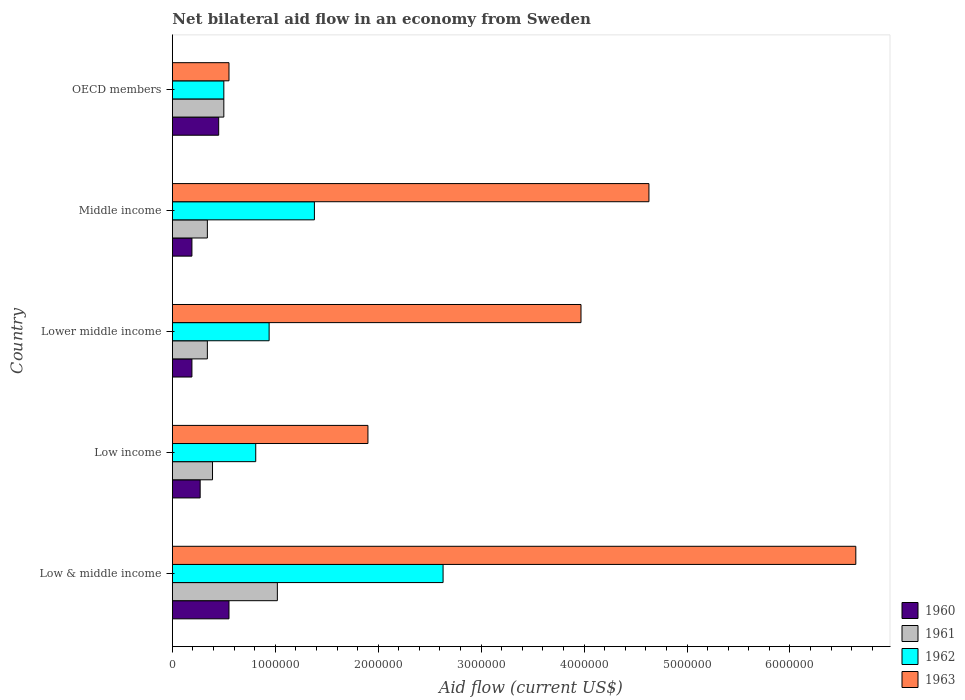How many groups of bars are there?
Your answer should be compact. 5. What is the label of the 3rd group of bars from the top?
Keep it short and to the point. Lower middle income. What is the net bilateral aid flow in 1962 in Lower middle income?
Give a very brief answer. 9.40e+05. Across all countries, what is the maximum net bilateral aid flow in 1961?
Your answer should be very brief. 1.02e+06. Across all countries, what is the minimum net bilateral aid flow in 1963?
Give a very brief answer. 5.50e+05. In which country was the net bilateral aid flow in 1963 minimum?
Give a very brief answer. OECD members. What is the total net bilateral aid flow in 1960 in the graph?
Offer a very short reply. 1.65e+06. What is the difference between the net bilateral aid flow in 1962 in Low & middle income and that in Low income?
Provide a succinct answer. 1.82e+06. What is the difference between the net bilateral aid flow in 1962 in Lower middle income and the net bilateral aid flow in 1960 in Middle income?
Give a very brief answer. 7.50e+05. What is the average net bilateral aid flow in 1962 per country?
Give a very brief answer. 1.25e+06. What is the difference between the net bilateral aid flow in 1960 and net bilateral aid flow in 1963 in Low & middle income?
Ensure brevity in your answer.  -6.09e+06. What is the ratio of the net bilateral aid flow in 1963 in Low income to that in Lower middle income?
Offer a very short reply. 0.48. Is the difference between the net bilateral aid flow in 1960 in Low & middle income and Middle income greater than the difference between the net bilateral aid flow in 1963 in Low & middle income and Middle income?
Provide a succinct answer. No. What is the difference between the highest and the lowest net bilateral aid flow in 1961?
Your answer should be compact. 6.80e+05. In how many countries, is the net bilateral aid flow in 1962 greater than the average net bilateral aid flow in 1962 taken over all countries?
Your answer should be very brief. 2. Is the sum of the net bilateral aid flow in 1960 in Low income and Middle income greater than the maximum net bilateral aid flow in 1963 across all countries?
Your answer should be compact. No. What does the 3rd bar from the top in Lower middle income represents?
Your answer should be very brief. 1961. What does the 2nd bar from the bottom in Middle income represents?
Your answer should be compact. 1961. Is it the case that in every country, the sum of the net bilateral aid flow in 1963 and net bilateral aid flow in 1962 is greater than the net bilateral aid flow in 1960?
Your answer should be compact. Yes. How many bars are there?
Provide a short and direct response. 20. Are all the bars in the graph horizontal?
Ensure brevity in your answer.  Yes. How many countries are there in the graph?
Your answer should be compact. 5. How many legend labels are there?
Your answer should be compact. 4. What is the title of the graph?
Provide a succinct answer. Net bilateral aid flow in an economy from Sweden. What is the label or title of the X-axis?
Offer a terse response. Aid flow (current US$). What is the label or title of the Y-axis?
Your answer should be compact. Country. What is the Aid flow (current US$) in 1960 in Low & middle income?
Your answer should be compact. 5.50e+05. What is the Aid flow (current US$) in 1961 in Low & middle income?
Provide a succinct answer. 1.02e+06. What is the Aid flow (current US$) in 1962 in Low & middle income?
Your response must be concise. 2.63e+06. What is the Aid flow (current US$) of 1963 in Low & middle income?
Give a very brief answer. 6.64e+06. What is the Aid flow (current US$) of 1961 in Low income?
Make the answer very short. 3.90e+05. What is the Aid flow (current US$) in 1962 in Low income?
Your answer should be very brief. 8.10e+05. What is the Aid flow (current US$) in 1963 in Low income?
Offer a terse response. 1.90e+06. What is the Aid flow (current US$) in 1962 in Lower middle income?
Offer a terse response. 9.40e+05. What is the Aid flow (current US$) in 1963 in Lower middle income?
Your response must be concise. 3.97e+06. What is the Aid flow (current US$) in 1960 in Middle income?
Keep it short and to the point. 1.90e+05. What is the Aid flow (current US$) of 1962 in Middle income?
Your answer should be very brief. 1.38e+06. What is the Aid flow (current US$) in 1963 in Middle income?
Provide a succinct answer. 4.63e+06. What is the Aid flow (current US$) of 1960 in OECD members?
Keep it short and to the point. 4.50e+05. What is the Aid flow (current US$) in 1961 in OECD members?
Offer a terse response. 5.00e+05. Across all countries, what is the maximum Aid flow (current US$) of 1961?
Keep it short and to the point. 1.02e+06. Across all countries, what is the maximum Aid flow (current US$) in 1962?
Keep it short and to the point. 2.63e+06. Across all countries, what is the maximum Aid flow (current US$) of 1963?
Ensure brevity in your answer.  6.64e+06. Across all countries, what is the minimum Aid flow (current US$) of 1960?
Offer a very short reply. 1.90e+05. Across all countries, what is the minimum Aid flow (current US$) of 1961?
Make the answer very short. 3.40e+05. What is the total Aid flow (current US$) in 1960 in the graph?
Make the answer very short. 1.65e+06. What is the total Aid flow (current US$) of 1961 in the graph?
Your answer should be compact. 2.59e+06. What is the total Aid flow (current US$) in 1962 in the graph?
Ensure brevity in your answer.  6.26e+06. What is the total Aid flow (current US$) of 1963 in the graph?
Your answer should be compact. 1.77e+07. What is the difference between the Aid flow (current US$) in 1960 in Low & middle income and that in Low income?
Ensure brevity in your answer.  2.80e+05. What is the difference between the Aid flow (current US$) in 1961 in Low & middle income and that in Low income?
Your answer should be very brief. 6.30e+05. What is the difference between the Aid flow (current US$) of 1962 in Low & middle income and that in Low income?
Offer a terse response. 1.82e+06. What is the difference between the Aid flow (current US$) of 1963 in Low & middle income and that in Low income?
Make the answer very short. 4.74e+06. What is the difference between the Aid flow (current US$) of 1960 in Low & middle income and that in Lower middle income?
Your answer should be very brief. 3.60e+05. What is the difference between the Aid flow (current US$) in 1961 in Low & middle income and that in Lower middle income?
Make the answer very short. 6.80e+05. What is the difference between the Aid flow (current US$) of 1962 in Low & middle income and that in Lower middle income?
Your answer should be compact. 1.69e+06. What is the difference between the Aid flow (current US$) in 1963 in Low & middle income and that in Lower middle income?
Provide a succinct answer. 2.67e+06. What is the difference between the Aid flow (current US$) in 1961 in Low & middle income and that in Middle income?
Give a very brief answer. 6.80e+05. What is the difference between the Aid flow (current US$) of 1962 in Low & middle income and that in Middle income?
Provide a succinct answer. 1.25e+06. What is the difference between the Aid flow (current US$) of 1963 in Low & middle income and that in Middle income?
Keep it short and to the point. 2.01e+06. What is the difference between the Aid flow (current US$) of 1960 in Low & middle income and that in OECD members?
Provide a short and direct response. 1.00e+05. What is the difference between the Aid flow (current US$) of 1961 in Low & middle income and that in OECD members?
Provide a short and direct response. 5.20e+05. What is the difference between the Aid flow (current US$) of 1962 in Low & middle income and that in OECD members?
Offer a terse response. 2.13e+06. What is the difference between the Aid flow (current US$) of 1963 in Low & middle income and that in OECD members?
Offer a terse response. 6.09e+06. What is the difference between the Aid flow (current US$) in 1961 in Low income and that in Lower middle income?
Provide a short and direct response. 5.00e+04. What is the difference between the Aid flow (current US$) in 1963 in Low income and that in Lower middle income?
Make the answer very short. -2.07e+06. What is the difference between the Aid flow (current US$) in 1962 in Low income and that in Middle income?
Provide a short and direct response. -5.70e+05. What is the difference between the Aid flow (current US$) in 1963 in Low income and that in Middle income?
Ensure brevity in your answer.  -2.73e+06. What is the difference between the Aid flow (current US$) in 1960 in Low income and that in OECD members?
Make the answer very short. -1.80e+05. What is the difference between the Aid flow (current US$) of 1963 in Low income and that in OECD members?
Provide a short and direct response. 1.35e+06. What is the difference between the Aid flow (current US$) in 1962 in Lower middle income and that in Middle income?
Your response must be concise. -4.40e+05. What is the difference between the Aid flow (current US$) of 1963 in Lower middle income and that in Middle income?
Provide a short and direct response. -6.60e+05. What is the difference between the Aid flow (current US$) in 1960 in Lower middle income and that in OECD members?
Make the answer very short. -2.60e+05. What is the difference between the Aid flow (current US$) of 1963 in Lower middle income and that in OECD members?
Make the answer very short. 3.42e+06. What is the difference between the Aid flow (current US$) of 1960 in Middle income and that in OECD members?
Make the answer very short. -2.60e+05. What is the difference between the Aid flow (current US$) in 1962 in Middle income and that in OECD members?
Your response must be concise. 8.80e+05. What is the difference between the Aid flow (current US$) of 1963 in Middle income and that in OECD members?
Your response must be concise. 4.08e+06. What is the difference between the Aid flow (current US$) of 1960 in Low & middle income and the Aid flow (current US$) of 1963 in Low income?
Make the answer very short. -1.35e+06. What is the difference between the Aid flow (current US$) of 1961 in Low & middle income and the Aid flow (current US$) of 1963 in Low income?
Your answer should be very brief. -8.80e+05. What is the difference between the Aid flow (current US$) in 1962 in Low & middle income and the Aid flow (current US$) in 1963 in Low income?
Keep it short and to the point. 7.30e+05. What is the difference between the Aid flow (current US$) of 1960 in Low & middle income and the Aid flow (current US$) of 1961 in Lower middle income?
Make the answer very short. 2.10e+05. What is the difference between the Aid flow (current US$) of 1960 in Low & middle income and the Aid flow (current US$) of 1962 in Lower middle income?
Provide a succinct answer. -3.90e+05. What is the difference between the Aid flow (current US$) of 1960 in Low & middle income and the Aid flow (current US$) of 1963 in Lower middle income?
Offer a very short reply. -3.42e+06. What is the difference between the Aid flow (current US$) of 1961 in Low & middle income and the Aid flow (current US$) of 1963 in Lower middle income?
Provide a succinct answer. -2.95e+06. What is the difference between the Aid flow (current US$) in 1962 in Low & middle income and the Aid flow (current US$) in 1963 in Lower middle income?
Provide a short and direct response. -1.34e+06. What is the difference between the Aid flow (current US$) of 1960 in Low & middle income and the Aid flow (current US$) of 1961 in Middle income?
Make the answer very short. 2.10e+05. What is the difference between the Aid flow (current US$) of 1960 in Low & middle income and the Aid flow (current US$) of 1962 in Middle income?
Your answer should be very brief. -8.30e+05. What is the difference between the Aid flow (current US$) in 1960 in Low & middle income and the Aid flow (current US$) in 1963 in Middle income?
Your answer should be very brief. -4.08e+06. What is the difference between the Aid flow (current US$) of 1961 in Low & middle income and the Aid flow (current US$) of 1962 in Middle income?
Give a very brief answer. -3.60e+05. What is the difference between the Aid flow (current US$) of 1961 in Low & middle income and the Aid flow (current US$) of 1963 in Middle income?
Make the answer very short. -3.61e+06. What is the difference between the Aid flow (current US$) in 1960 in Low & middle income and the Aid flow (current US$) in 1961 in OECD members?
Your answer should be compact. 5.00e+04. What is the difference between the Aid flow (current US$) of 1961 in Low & middle income and the Aid flow (current US$) of 1962 in OECD members?
Make the answer very short. 5.20e+05. What is the difference between the Aid flow (current US$) of 1961 in Low & middle income and the Aid flow (current US$) of 1963 in OECD members?
Your answer should be compact. 4.70e+05. What is the difference between the Aid flow (current US$) of 1962 in Low & middle income and the Aid flow (current US$) of 1963 in OECD members?
Give a very brief answer. 2.08e+06. What is the difference between the Aid flow (current US$) of 1960 in Low income and the Aid flow (current US$) of 1962 in Lower middle income?
Provide a succinct answer. -6.70e+05. What is the difference between the Aid flow (current US$) in 1960 in Low income and the Aid flow (current US$) in 1963 in Lower middle income?
Your answer should be compact. -3.70e+06. What is the difference between the Aid flow (current US$) in 1961 in Low income and the Aid flow (current US$) in 1962 in Lower middle income?
Give a very brief answer. -5.50e+05. What is the difference between the Aid flow (current US$) in 1961 in Low income and the Aid flow (current US$) in 1963 in Lower middle income?
Make the answer very short. -3.58e+06. What is the difference between the Aid flow (current US$) of 1962 in Low income and the Aid flow (current US$) of 1963 in Lower middle income?
Keep it short and to the point. -3.16e+06. What is the difference between the Aid flow (current US$) in 1960 in Low income and the Aid flow (current US$) in 1962 in Middle income?
Give a very brief answer. -1.11e+06. What is the difference between the Aid flow (current US$) in 1960 in Low income and the Aid flow (current US$) in 1963 in Middle income?
Your answer should be very brief. -4.36e+06. What is the difference between the Aid flow (current US$) of 1961 in Low income and the Aid flow (current US$) of 1962 in Middle income?
Keep it short and to the point. -9.90e+05. What is the difference between the Aid flow (current US$) in 1961 in Low income and the Aid flow (current US$) in 1963 in Middle income?
Your response must be concise. -4.24e+06. What is the difference between the Aid flow (current US$) of 1962 in Low income and the Aid flow (current US$) of 1963 in Middle income?
Your answer should be very brief. -3.82e+06. What is the difference between the Aid flow (current US$) in 1960 in Low income and the Aid flow (current US$) in 1961 in OECD members?
Offer a terse response. -2.30e+05. What is the difference between the Aid flow (current US$) of 1960 in Low income and the Aid flow (current US$) of 1963 in OECD members?
Your response must be concise. -2.80e+05. What is the difference between the Aid flow (current US$) in 1960 in Lower middle income and the Aid flow (current US$) in 1961 in Middle income?
Offer a very short reply. -1.50e+05. What is the difference between the Aid flow (current US$) of 1960 in Lower middle income and the Aid flow (current US$) of 1962 in Middle income?
Ensure brevity in your answer.  -1.19e+06. What is the difference between the Aid flow (current US$) of 1960 in Lower middle income and the Aid flow (current US$) of 1963 in Middle income?
Provide a succinct answer. -4.44e+06. What is the difference between the Aid flow (current US$) of 1961 in Lower middle income and the Aid flow (current US$) of 1962 in Middle income?
Your response must be concise. -1.04e+06. What is the difference between the Aid flow (current US$) of 1961 in Lower middle income and the Aid flow (current US$) of 1963 in Middle income?
Your answer should be compact. -4.29e+06. What is the difference between the Aid flow (current US$) of 1962 in Lower middle income and the Aid flow (current US$) of 1963 in Middle income?
Offer a very short reply. -3.69e+06. What is the difference between the Aid flow (current US$) in 1960 in Lower middle income and the Aid flow (current US$) in 1961 in OECD members?
Ensure brevity in your answer.  -3.10e+05. What is the difference between the Aid flow (current US$) in 1960 in Lower middle income and the Aid flow (current US$) in 1962 in OECD members?
Your answer should be compact. -3.10e+05. What is the difference between the Aid flow (current US$) in 1960 in Lower middle income and the Aid flow (current US$) in 1963 in OECD members?
Offer a terse response. -3.60e+05. What is the difference between the Aid flow (current US$) of 1961 in Lower middle income and the Aid flow (current US$) of 1962 in OECD members?
Your response must be concise. -1.60e+05. What is the difference between the Aid flow (current US$) in 1960 in Middle income and the Aid flow (current US$) in 1961 in OECD members?
Your answer should be compact. -3.10e+05. What is the difference between the Aid flow (current US$) of 1960 in Middle income and the Aid flow (current US$) of 1962 in OECD members?
Ensure brevity in your answer.  -3.10e+05. What is the difference between the Aid flow (current US$) in 1960 in Middle income and the Aid flow (current US$) in 1963 in OECD members?
Offer a very short reply. -3.60e+05. What is the difference between the Aid flow (current US$) in 1961 in Middle income and the Aid flow (current US$) in 1962 in OECD members?
Give a very brief answer. -1.60e+05. What is the difference between the Aid flow (current US$) of 1961 in Middle income and the Aid flow (current US$) of 1963 in OECD members?
Keep it short and to the point. -2.10e+05. What is the difference between the Aid flow (current US$) in 1962 in Middle income and the Aid flow (current US$) in 1963 in OECD members?
Your answer should be very brief. 8.30e+05. What is the average Aid flow (current US$) of 1960 per country?
Offer a terse response. 3.30e+05. What is the average Aid flow (current US$) in 1961 per country?
Offer a very short reply. 5.18e+05. What is the average Aid flow (current US$) in 1962 per country?
Offer a terse response. 1.25e+06. What is the average Aid flow (current US$) of 1963 per country?
Your answer should be compact. 3.54e+06. What is the difference between the Aid flow (current US$) in 1960 and Aid flow (current US$) in 1961 in Low & middle income?
Your answer should be very brief. -4.70e+05. What is the difference between the Aid flow (current US$) of 1960 and Aid flow (current US$) of 1962 in Low & middle income?
Ensure brevity in your answer.  -2.08e+06. What is the difference between the Aid flow (current US$) in 1960 and Aid flow (current US$) in 1963 in Low & middle income?
Keep it short and to the point. -6.09e+06. What is the difference between the Aid flow (current US$) of 1961 and Aid flow (current US$) of 1962 in Low & middle income?
Your response must be concise. -1.61e+06. What is the difference between the Aid flow (current US$) of 1961 and Aid flow (current US$) of 1963 in Low & middle income?
Provide a short and direct response. -5.62e+06. What is the difference between the Aid flow (current US$) in 1962 and Aid flow (current US$) in 1963 in Low & middle income?
Offer a very short reply. -4.01e+06. What is the difference between the Aid flow (current US$) in 1960 and Aid flow (current US$) in 1962 in Low income?
Ensure brevity in your answer.  -5.40e+05. What is the difference between the Aid flow (current US$) in 1960 and Aid flow (current US$) in 1963 in Low income?
Keep it short and to the point. -1.63e+06. What is the difference between the Aid flow (current US$) in 1961 and Aid flow (current US$) in 1962 in Low income?
Ensure brevity in your answer.  -4.20e+05. What is the difference between the Aid flow (current US$) in 1961 and Aid flow (current US$) in 1963 in Low income?
Offer a terse response. -1.51e+06. What is the difference between the Aid flow (current US$) of 1962 and Aid flow (current US$) of 1963 in Low income?
Offer a terse response. -1.09e+06. What is the difference between the Aid flow (current US$) in 1960 and Aid flow (current US$) in 1962 in Lower middle income?
Your answer should be compact. -7.50e+05. What is the difference between the Aid flow (current US$) of 1960 and Aid flow (current US$) of 1963 in Lower middle income?
Provide a succinct answer. -3.78e+06. What is the difference between the Aid flow (current US$) of 1961 and Aid flow (current US$) of 1962 in Lower middle income?
Offer a terse response. -6.00e+05. What is the difference between the Aid flow (current US$) of 1961 and Aid flow (current US$) of 1963 in Lower middle income?
Offer a very short reply. -3.63e+06. What is the difference between the Aid flow (current US$) of 1962 and Aid flow (current US$) of 1963 in Lower middle income?
Give a very brief answer. -3.03e+06. What is the difference between the Aid flow (current US$) in 1960 and Aid flow (current US$) in 1961 in Middle income?
Give a very brief answer. -1.50e+05. What is the difference between the Aid flow (current US$) of 1960 and Aid flow (current US$) of 1962 in Middle income?
Provide a short and direct response. -1.19e+06. What is the difference between the Aid flow (current US$) in 1960 and Aid flow (current US$) in 1963 in Middle income?
Keep it short and to the point. -4.44e+06. What is the difference between the Aid flow (current US$) in 1961 and Aid flow (current US$) in 1962 in Middle income?
Your response must be concise. -1.04e+06. What is the difference between the Aid flow (current US$) in 1961 and Aid flow (current US$) in 1963 in Middle income?
Your answer should be very brief. -4.29e+06. What is the difference between the Aid flow (current US$) of 1962 and Aid flow (current US$) of 1963 in Middle income?
Offer a very short reply. -3.25e+06. What is the difference between the Aid flow (current US$) in 1960 and Aid flow (current US$) in 1961 in OECD members?
Offer a terse response. -5.00e+04. What is the difference between the Aid flow (current US$) of 1960 and Aid flow (current US$) of 1962 in OECD members?
Offer a very short reply. -5.00e+04. What is the difference between the Aid flow (current US$) of 1960 and Aid flow (current US$) of 1963 in OECD members?
Your answer should be compact. -1.00e+05. What is the difference between the Aid flow (current US$) in 1961 and Aid flow (current US$) in 1962 in OECD members?
Ensure brevity in your answer.  0. What is the difference between the Aid flow (current US$) in 1961 and Aid flow (current US$) in 1963 in OECD members?
Your response must be concise. -5.00e+04. What is the ratio of the Aid flow (current US$) of 1960 in Low & middle income to that in Low income?
Your answer should be compact. 2.04. What is the ratio of the Aid flow (current US$) of 1961 in Low & middle income to that in Low income?
Keep it short and to the point. 2.62. What is the ratio of the Aid flow (current US$) of 1962 in Low & middle income to that in Low income?
Keep it short and to the point. 3.25. What is the ratio of the Aid flow (current US$) in 1963 in Low & middle income to that in Low income?
Offer a very short reply. 3.49. What is the ratio of the Aid flow (current US$) in 1960 in Low & middle income to that in Lower middle income?
Your answer should be compact. 2.89. What is the ratio of the Aid flow (current US$) of 1961 in Low & middle income to that in Lower middle income?
Provide a short and direct response. 3. What is the ratio of the Aid flow (current US$) in 1962 in Low & middle income to that in Lower middle income?
Give a very brief answer. 2.8. What is the ratio of the Aid flow (current US$) of 1963 in Low & middle income to that in Lower middle income?
Provide a short and direct response. 1.67. What is the ratio of the Aid flow (current US$) of 1960 in Low & middle income to that in Middle income?
Keep it short and to the point. 2.89. What is the ratio of the Aid flow (current US$) in 1961 in Low & middle income to that in Middle income?
Provide a short and direct response. 3. What is the ratio of the Aid flow (current US$) of 1962 in Low & middle income to that in Middle income?
Offer a terse response. 1.91. What is the ratio of the Aid flow (current US$) of 1963 in Low & middle income to that in Middle income?
Your response must be concise. 1.43. What is the ratio of the Aid flow (current US$) of 1960 in Low & middle income to that in OECD members?
Make the answer very short. 1.22. What is the ratio of the Aid flow (current US$) of 1961 in Low & middle income to that in OECD members?
Offer a terse response. 2.04. What is the ratio of the Aid flow (current US$) in 1962 in Low & middle income to that in OECD members?
Provide a succinct answer. 5.26. What is the ratio of the Aid flow (current US$) of 1963 in Low & middle income to that in OECD members?
Your answer should be compact. 12.07. What is the ratio of the Aid flow (current US$) of 1960 in Low income to that in Lower middle income?
Your answer should be compact. 1.42. What is the ratio of the Aid flow (current US$) of 1961 in Low income to that in Lower middle income?
Give a very brief answer. 1.15. What is the ratio of the Aid flow (current US$) of 1962 in Low income to that in Lower middle income?
Your answer should be compact. 0.86. What is the ratio of the Aid flow (current US$) in 1963 in Low income to that in Lower middle income?
Your answer should be very brief. 0.48. What is the ratio of the Aid flow (current US$) of 1960 in Low income to that in Middle income?
Offer a very short reply. 1.42. What is the ratio of the Aid flow (current US$) in 1961 in Low income to that in Middle income?
Offer a terse response. 1.15. What is the ratio of the Aid flow (current US$) of 1962 in Low income to that in Middle income?
Your answer should be compact. 0.59. What is the ratio of the Aid flow (current US$) of 1963 in Low income to that in Middle income?
Provide a short and direct response. 0.41. What is the ratio of the Aid flow (current US$) of 1961 in Low income to that in OECD members?
Your response must be concise. 0.78. What is the ratio of the Aid flow (current US$) of 1962 in Low income to that in OECD members?
Ensure brevity in your answer.  1.62. What is the ratio of the Aid flow (current US$) of 1963 in Low income to that in OECD members?
Make the answer very short. 3.45. What is the ratio of the Aid flow (current US$) of 1962 in Lower middle income to that in Middle income?
Make the answer very short. 0.68. What is the ratio of the Aid flow (current US$) in 1963 in Lower middle income to that in Middle income?
Give a very brief answer. 0.86. What is the ratio of the Aid flow (current US$) in 1960 in Lower middle income to that in OECD members?
Offer a terse response. 0.42. What is the ratio of the Aid flow (current US$) of 1961 in Lower middle income to that in OECD members?
Offer a very short reply. 0.68. What is the ratio of the Aid flow (current US$) of 1962 in Lower middle income to that in OECD members?
Offer a terse response. 1.88. What is the ratio of the Aid flow (current US$) of 1963 in Lower middle income to that in OECD members?
Offer a very short reply. 7.22. What is the ratio of the Aid flow (current US$) in 1960 in Middle income to that in OECD members?
Give a very brief answer. 0.42. What is the ratio of the Aid flow (current US$) of 1961 in Middle income to that in OECD members?
Give a very brief answer. 0.68. What is the ratio of the Aid flow (current US$) in 1962 in Middle income to that in OECD members?
Provide a short and direct response. 2.76. What is the ratio of the Aid flow (current US$) in 1963 in Middle income to that in OECD members?
Offer a very short reply. 8.42. What is the difference between the highest and the second highest Aid flow (current US$) in 1961?
Offer a terse response. 5.20e+05. What is the difference between the highest and the second highest Aid flow (current US$) in 1962?
Provide a short and direct response. 1.25e+06. What is the difference between the highest and the second highest Aid flow (current US$) in 1963?
Your answer should be compact. 2.01e+06. What is the difference between the highest and the lowest Aid flow (current US$) in 1961?
Offer a terse response. 6.80e+05. What is the difference between the highest and the lowest Aid flow (current US$) in 1962?
Provide a succinct answer. 2.13e+06. What is the difference between the highest and the lowest Aid flow (current US$) of 1963?
Offer a terse response. 6.09e+06. 